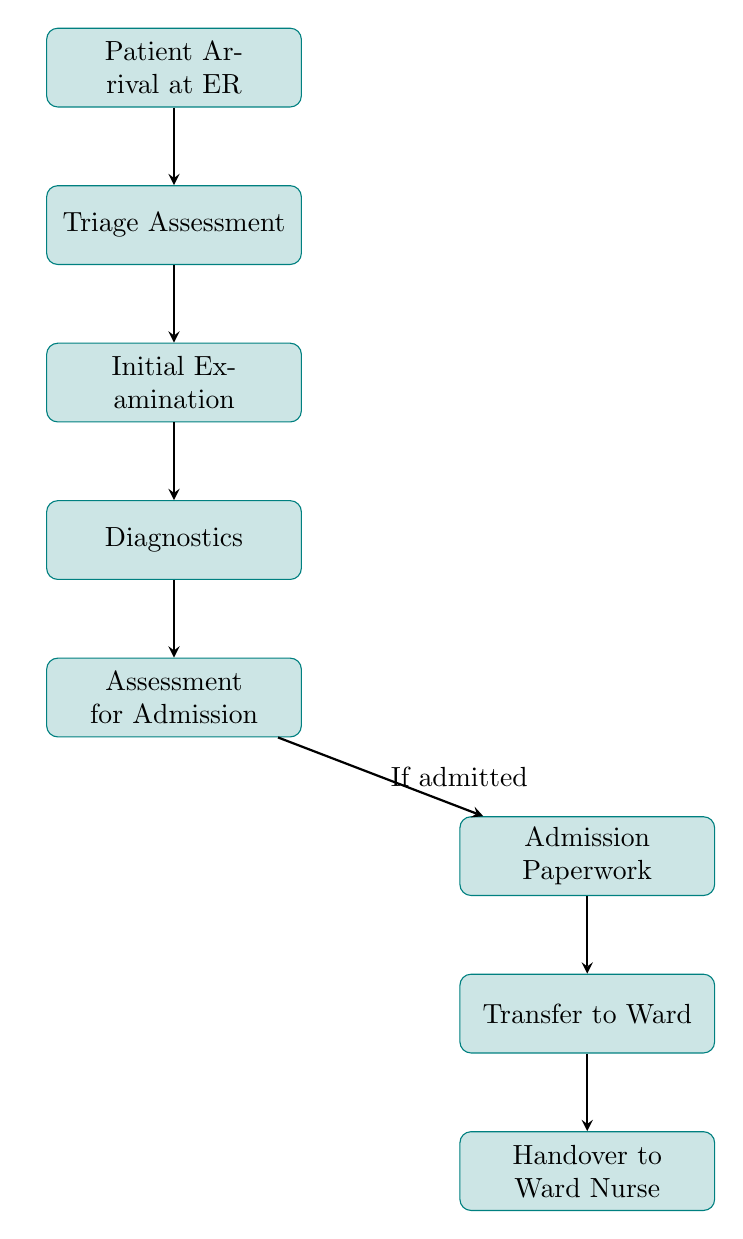What is the first step in the patient admission process? The first step is the "Patient Arrival at ER," where the patient checks in at the Emergency Room.
Answer: Patient Arrival at ER How many nodes are in the flow chart? The flow chart has a total of eight nodes representing different steps in the patient admission process.
Answer: 8 What step follows 'Diagnostics'? Following 'Diagnostics', the next step is 'Assessment for Admission'. This indicates that after diagnostic tests, the patient's need for admission is evaluated.
Answer: Assessment for Admission What action is taken if the patient is admitted? If the patient is admitted, the next action is to complete the 'Admission Paperwork' necessary for the formal entry into the ward.
Answer: Admission Paperwork What is the final step in the flow chart? The final step in the flow chart is 'Handover to Ward Nurse', which involves transferring information about the patient to the nurse in the ward.
Answer: Handover to Ward Nurse What is the relationship between 'Transfer to Ward' and 'Handover to Ward Nurse'? The relationship is sequential; 'Transfer to Ward' occurs first and is followed by 'Handover to Ward Nurse', indicating the process of moving the patient and informing the ward nurse.
Answer: Sequential relationship Which step involves conducting tests like blood work or X-rays? The step involving tests such as blood work and X-rays is 'Diagnostics', where necessary medical evaluations are carried out to assess the patient's condition.
Answer: Diagnostics What does the triage nurse do in the process? The triage nurse assesses the patient's condition during the 'Triage Assessment', which is the second step after the patient arrives.
Answer: Assesses the patient's condition 